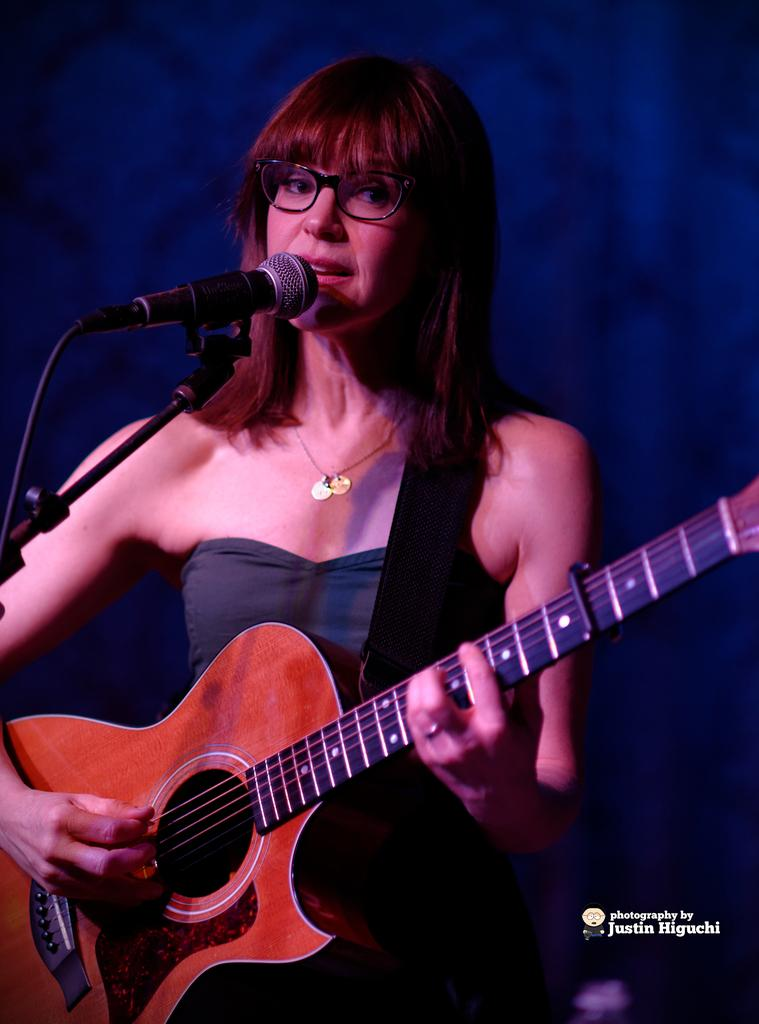Who is the main subject in the image? There is a woman in the image. What is the woman doing in the image? The woman is standing and singing into a microphone. What object is the woman holding in the image? The woman is holding a guitar in the image. What type of island can be seen in the background of the image? There is no island visible in the image; it features a woman standing, singing into a microphone, and holding a guitar. What type of flesh is visible on the woman's hands in the image? There is no flesh visible on the woman's hands in the image; it is a photograph, and the woman's hands are covered by the guitar. 